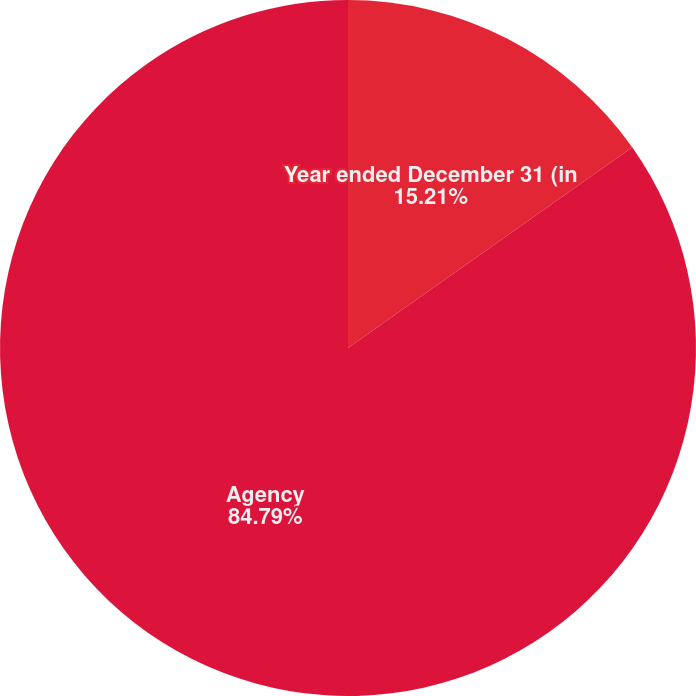Convert chart to OTSL. <chart><loc_0><loc_0><loc_500><loc_500><pie_chart><fcel>Year ended December 31 (in<fcel>Agency<nl><fcel>15.21%<fcel>84.79%<nl></chart> 